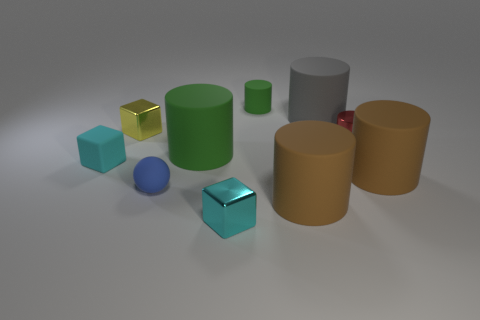How many blocks have the same material as the yellow thing?
Offer a very short reply. 1. The yellow thing that is the same shape as the tiny cyan matte object is what size?
Give a very brief answer. Small. Is the size of the yellow metal block the same as the cyan matte cube?
Offer a terse response. Yes. There is a tiny shiny object that is in front of the large rubber cylinder that is on the left side of the green object that is right of the big green matte thing; what is its shape?
Your answer should be compact. Cube. There is another small thing that is the same shape as the small green matte object; what is its color?
Give a very brief answer. Red. What is the size of the cube that is in front of the small red shiny cylinder and behind the small blue rubber sphere?
Ensure brevity in your answer.  Small. What number of blue balls are right of the small matte object to the right of the green rubber thing left of the tiny cyan metallic block?
Ensure brevity in your answer.  0. How many small things are either metal objects or metallic cubes?
Your response must be concise. 3. Is the material of the cylinder that is on the left side of the small green matte cylinder the same as the tiny ball?
Your answer should be compact. Yes. The green cylinder left of the shiny block that is to the right of the tiny metal block behind the big green object is made of what material?
Provide a short and direct response. Rubber. 